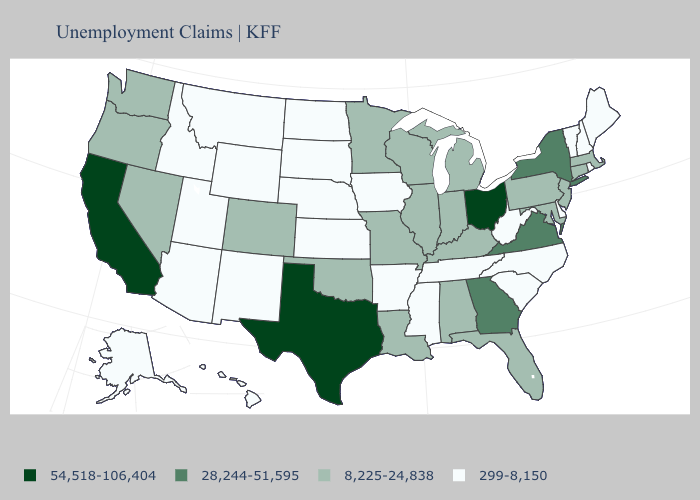How many symbols are there in the legend?
Be succinct. 4. Does the map have missing data?
Concise answer only. No. Does New York have the highest value in the Northeast?
Answer briefly. Yes. Among the states that border Idaho , which have the highest value?
Give a very brief answer. Nevada, Oregon, Washington. Which states have the highest value in the USA?
Concise answer only. California, Ohio, Texas. Does Maryland have the highest value in the USA?
Be succinct. No. Among the states that border Maine , which have the lowest value?
Answer briefly. New Hampshire. Does South Dakota have the same value as Mississippi?
Concise answer only. Yes. Does Texas have the highest value in the South?
Short answer required. Yes. Does Montana have a higher value than South Carolina?
Give a very brief answer. No. Name the states that have a value in the range 54,518-106,404?
Give a very brief answer. California, Ohio, Texas. Name the states that have a value in the range 8,225-24,838?
Quick response, please. Alabama, Colorado, Connecticut, Florida, Illinois, Indiana, Kentucky, Louisiana, Maryland, Massachusetts, Michigan, Minnesota, Missouri, Nevada, New Jersey, Oklahoma, Oregon, Pennsylvania, Washington, Wisconsin. Does New Mexico have the lowest value in the West?
Be succinct. Yes. How many symbols are there in the legend?
Concise answer only. 4. What is the lowest value in the USA?
Write a very short answer. 299-8,150. 